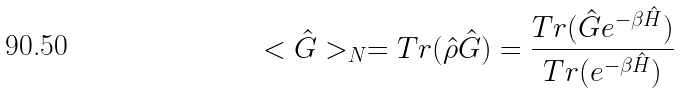<formula> <loc_0><loc_0><loc_500><loc_500>< \hat { G } > _ { N } = T r ( \hat { \rho } \hat { G } ) = \frac { T r ( \hat { G } e ^ { - \beta \hat { H } } ) } { T r ( e ^ { - \beta \hat { H } } ) }</formula> 